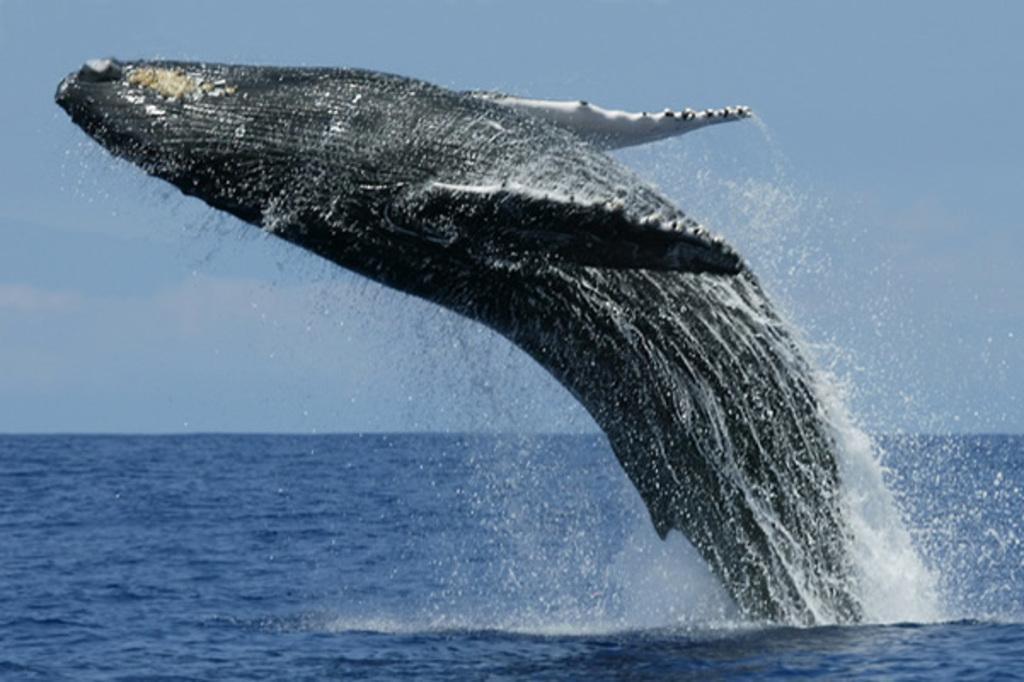How would you summarize this image in a sentence or two? In the image there is a whale swimming out from the water surface. 